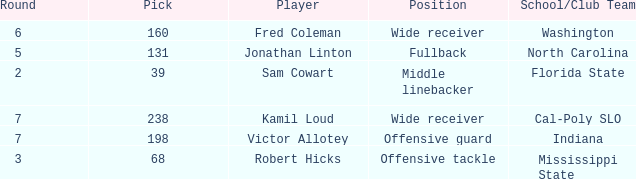Which Player has a Round smaller than 5, and a School/Club Team of florida state? Sam Cowart. 